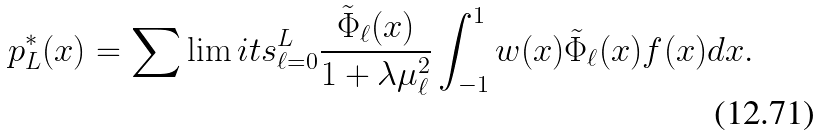<formula> <loc_0><loc_0><loc_500><loc_500>p _ { L } ^ { * } ( x ) = \sum \lim i t s _ { \ell = 0 } ^ { L } \frac { \tilde { \Phi } _ { \ell } ( x ) } { 1 + \lambda \mu _ { \ell } ^ { 2 } } \int _ { - 1 } ^ { 1 } w ( x ) \tilde { \Phi } _ { \ell } ( x ) f ( x ) d x .</formula> 